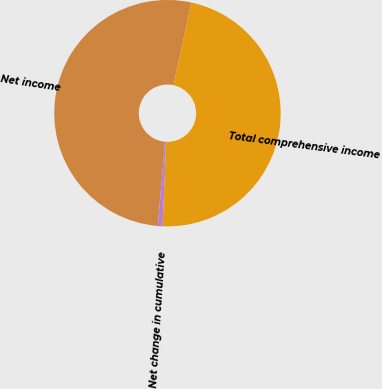<chart> <loc_0><loc_0><loc_500><loc_500><pie_chart><fcel>Net income<fcel>Net change in cumulative<fcel>Total comprehensive income<nl><fcel>52.03%<fcel>0.67%<fcel>47.3%<nl></chart> 